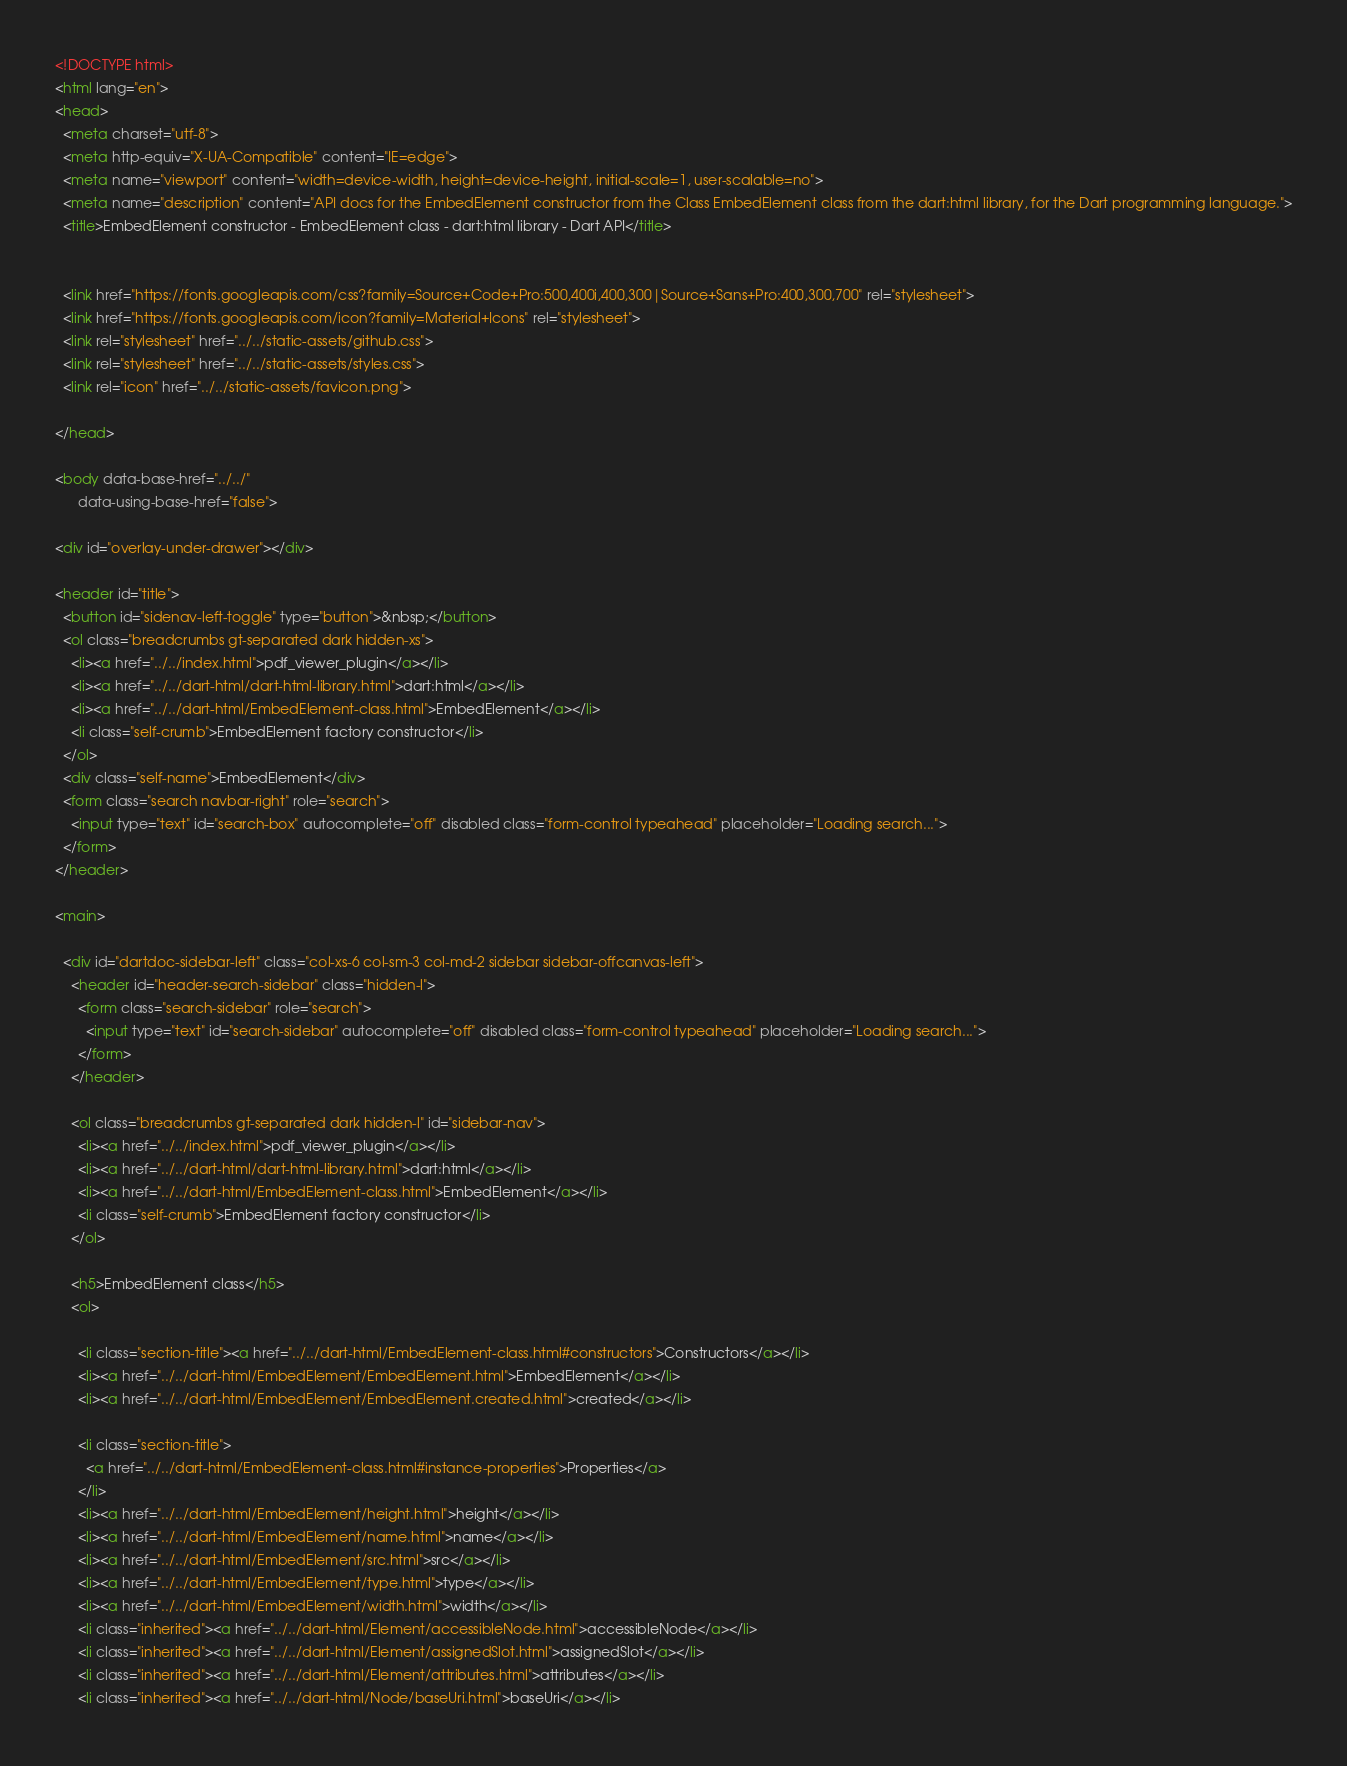Convert code to text. <code><loc_0><loc_0><loc_500><loc_500><_HTML_><!DOCTYPE html>
<html lang="en">
<head>
  <meta charset="utf-8">
  <meta http-equiv="X-UA-Compatible" content="IE=edge">
  <meta name="viewport" content="width=device-width, height=device-height, initial-scale=1, user-scalable=no">
  <meta name="description" content="API docs for the EmbedElement constructor from the Class EmbedElement class from the dart:html library, for the Dart programming language.">
  <title>EmbedElement constructor - EmbedElement class - dart:html library - Dart API</title>

  
  <link href="https://fonts.googleapis.com/css?family=Source+Code+Pro:500,400i,400,300|Source+Sans+Pro:400,300,700" rel="stylesheet">
  <link href="https://fonts.googleapis.com/icon?family=Material+Icons" rel="stylesheet">
  <link rel="stylesheet" href="../../static-assets/github.css">
  <link rel="stylesheet" href="../../static-assets/styles.css">
  <link rel="icon" href="../../static-assets/favicon.png">

</head>

<body data-base-href="../../"
      data-using-base-href="false">

<div id="overlay-under-drawer"></div>

<header id="title">
  <button id="sidenav-left-toggle" type="button">&nbsp;</button>
  <ol class="breadcrumbs gt-separated dark hidden-xs">
    <li><a href="../../index.html">pdf_viewer_plugin</a></li>
    <li><a href="../../dart-html/dart-html-library.html">dart:html</a></li>
    <li><a href="../../dart-html/EmbedElement-class.html">EmbedElement</a></li>
    <li class="self-crumb">EmbedElement factory constructor</li>
  </ol>
  <div class="self-name">EmbedElement</div>
  <form class="search navbar-right" role="search">
    <input type="text" id="search-box" autocomplete="off" disabled class="form-control typeahead" placeholder="Loading search...">
  </form>
</header>

<main>

  <div id="dartdoc-sidebar-left" class="col-xs-6 col-sm-3 col-md-2 sidebar sidebar-offcanvas-left">
    <header id="header-search-sidebar" class="hidden-l">
      <form class="search-sidebar" role="search">
        <input type="text" id="search-sidebar" autocomplete="off" disabled class="form-control typeahead" placeholder="Loading search...">
      </form>
    </header>
    
    <ol class="breadcrumbs gt-separated dark hidden-l" id="sidebar-nav">
      <li><a href="../../index.html">pdf_viewer_plugin</a></li>
      <li><a href="../../dart-html/dart-html-library.html">dart:html</a></li>
      <li><a href="../../dart-html/EmbedElement-class.html">EmbedElement</a></li>
      <li class="self-crumb">EmbedElement factory constructor</li>
    </ol>
    
    <h5>EmbedElement class</h5>
    <ol>
    
      <li class="section-title"><a href="../../dart-html/EmbedElement-class.html#constructors">Constructors</a></li>
      <li><a href="../../dart-html/EmbedElement/EmbedElement.html">EmbedElement</a></li>
      <li><a href="../../dart-html/EmbedElement/EmbedElement.created.html">created</a></li>
    
      <li class="section-title">
        <a href="../../dart-html/EmbedElement-class.html#instance-properties">Properties</a>
      </li>
      <li><a href="../../dart-html/EmbedElement/height.html">height</a></li>
      <li><a href="../../dart-html/EmbedElement/name.html">name</a></li>
      <li><a href="../../dart-html/EmbedElement/src.html">src</a></li>
      <li><a href="../../dart-html/EmbedElement/type.html">type</a></li>
      <li><a href="../../dart-html/EmbedElement/width.html">width</a></li>
      <li class="inherited"><a href="../../dart-html/Element/accessibleNode.html">accessibleNode</a></li>
      <li class="inherited"><a href="../../dart-html/Element/assignedSlot.html">assignedSlot</a></li>
      <li class="inherited"><a href="../../dart-html/Element/attributes.html">attributes</a></li>
      <li class="inherited"><a href="../../dart-html/Node/baseUri.html">baseUri</a></li></code> 